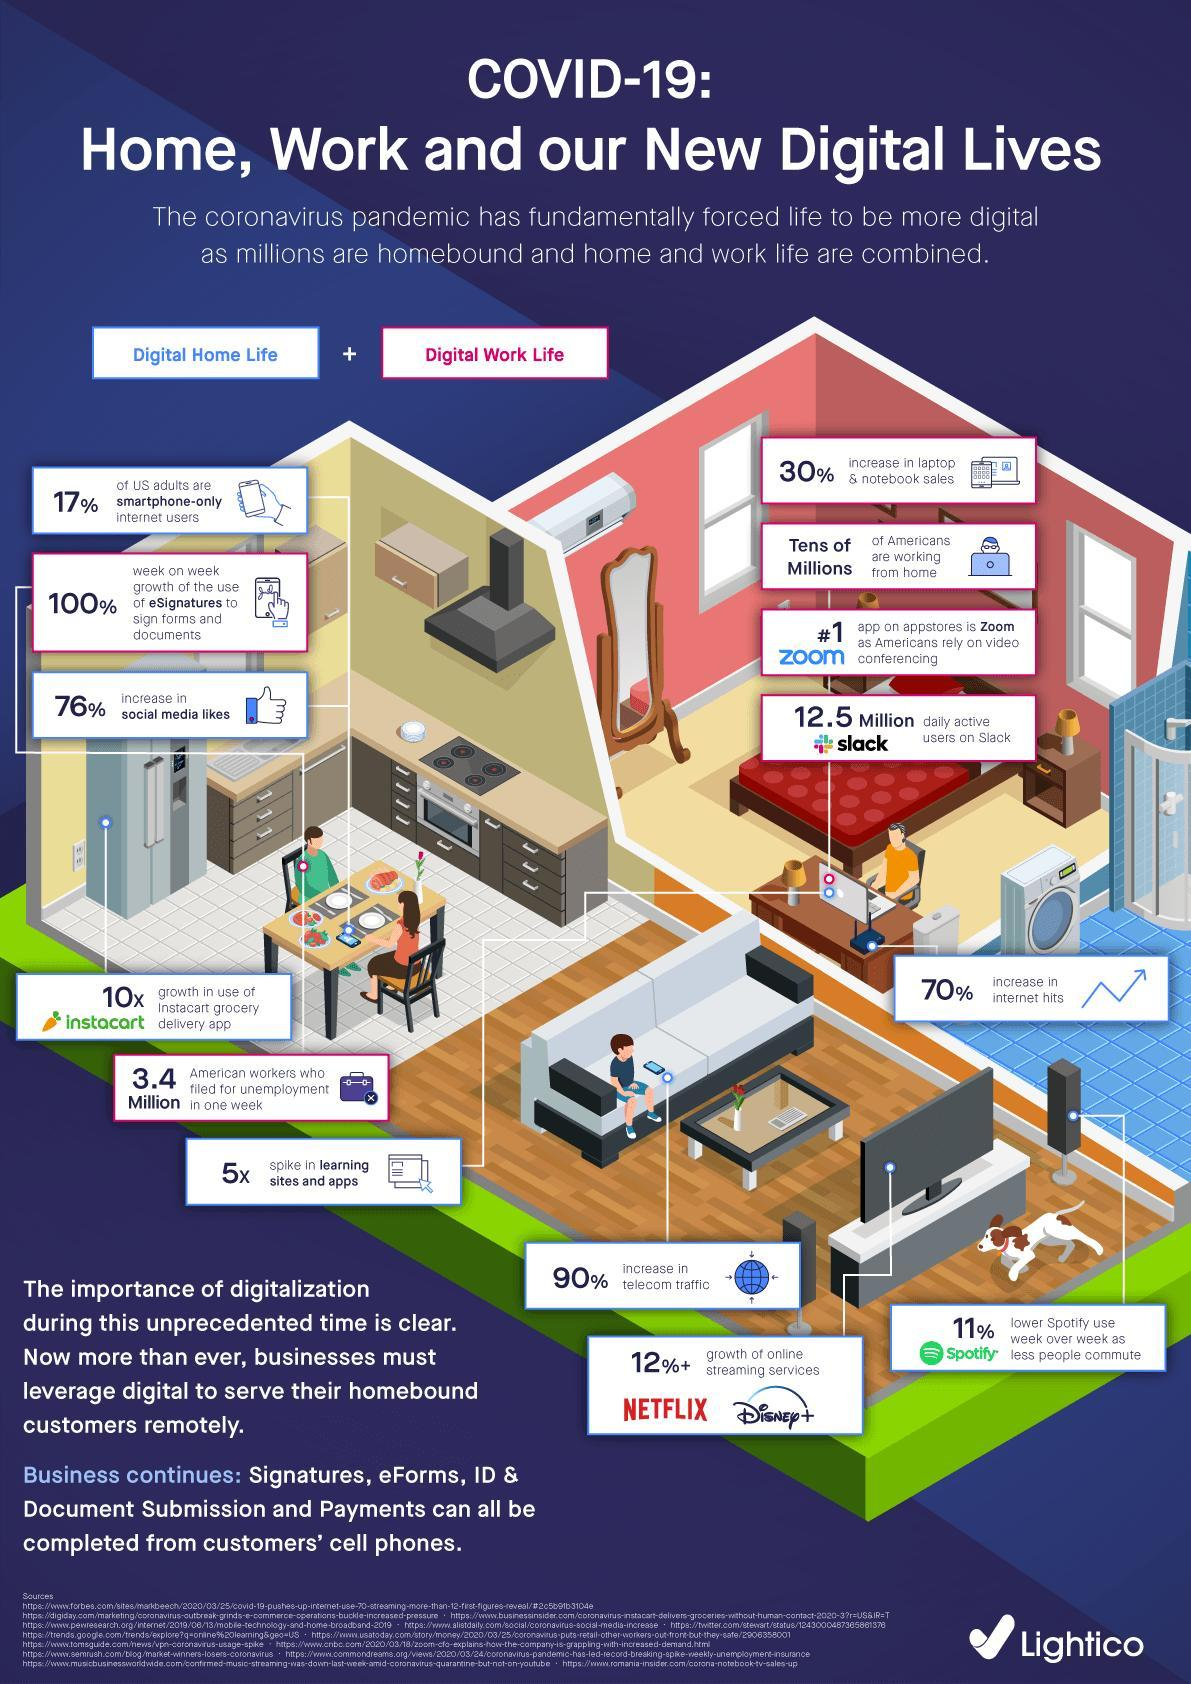How many Americans are working from home as a result of the COVID-19 outbreak?
Answer the question with a short phrase. Tens of Millions What percentage increase is seen in the telecom traffic due to the COVID-19 impact? 90% Which app is widely used by the Americans for video conferencing? zoom How many American workers have filed for unemployment in one week due to the COVID-19 impact? 3.4 Million What is the percentage increase in laptop & notebook sales due to the COVID-19 impact? 30% What is the percentage increase in the online streaming services due to the COVID-19 impact? 12%+ 